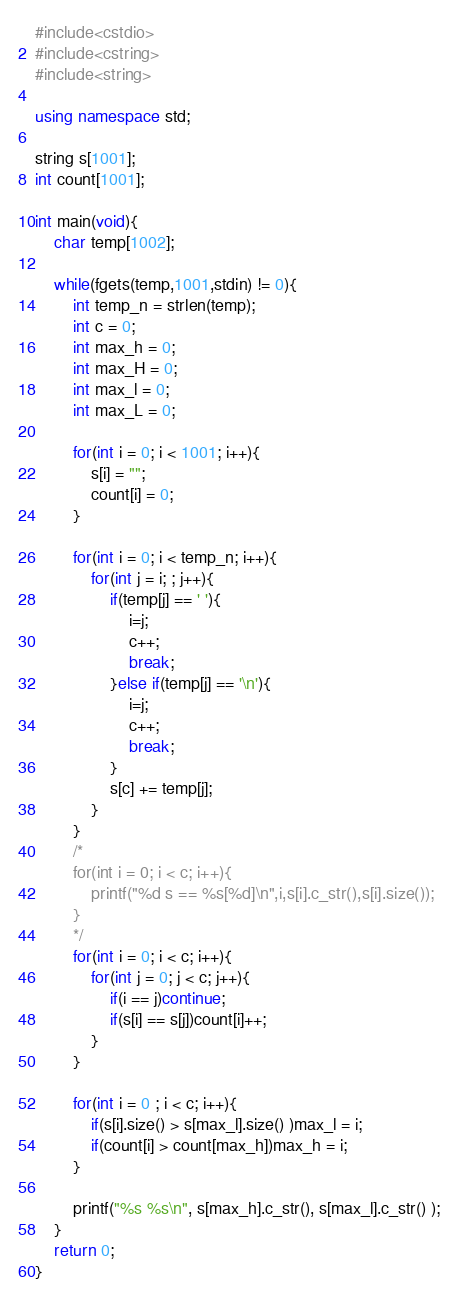<code> <loc_0><loc_0><loc_500><loc_500><_C++_>#include<cstdio>
#include<cstring>
#include<string>

using namespace std;

string s[1001];
int count[1001];

int main(void){
	char temp[1002];
	
	while(fgets(temp,1001,stdin) != 0){
		int temp_n = strlen(temp);
		int c = 0;
		int max_h = 0;
		int max_H = 0;
		int max_l = 0;
		int max_L = 0;
		
		for(int i = 0; i < 1001; i++){
			s[i] = "";
			count[i] = 0;
		}
		
		for(int i = 0; i < temp_n; i++){
			for(int j = i; ; j++){
				if(temp[j] == ' '){
					i=j;
					c++;
					break;
				}else if(temp[j] == '\n'){
					i=j;
					c++;
					break;
				}
				s[c] += temp[j];
			}
		}
		/*
		for(int i = 0; i < c; i++){
			printf("%d s == %s[%d]\n",i,s[i].c_str(),s[i].size());
		}
		*/
		for(int i = 0; i < c; i++){
			for(int j = 0; j < c; j++){
				if(i == j)continue;
				if(s[i] == s[j])count[i]++;
			}
		}
		
		for(int i = 0 ; i < c; i++){
			if(s[i].size() > s[max_l].size() )max_l = i;
			if(count[i] > count[max_h])max_h = i;
		}
		
		printf("%s %s\n", s[max_h].c_str(), s[max_l].c_str() );
	}
	return 0;
}</code> 